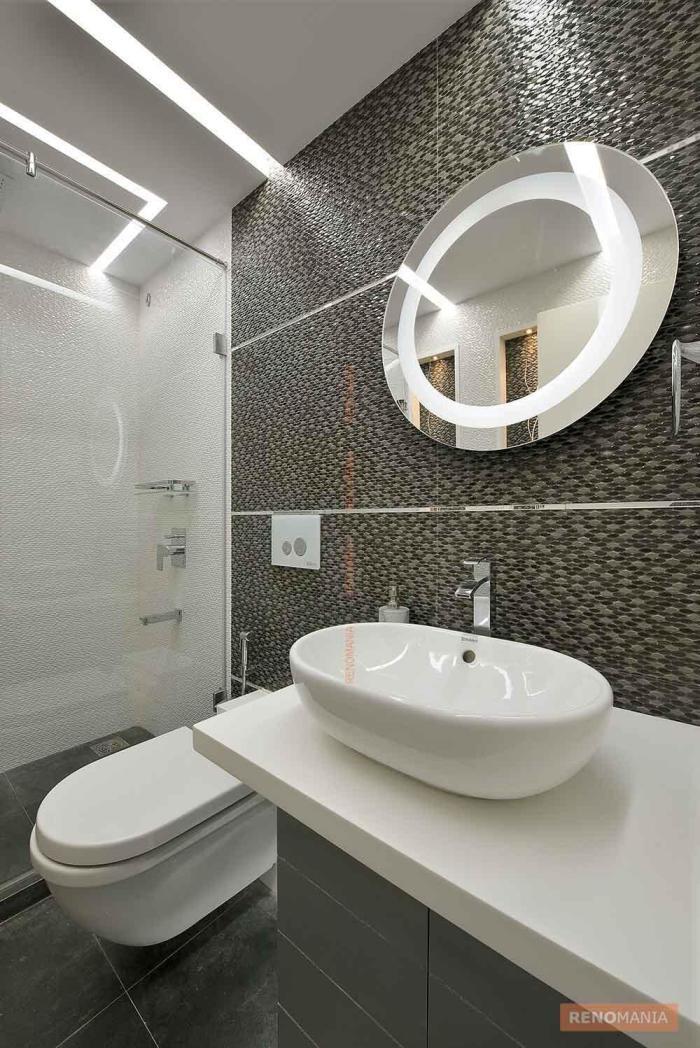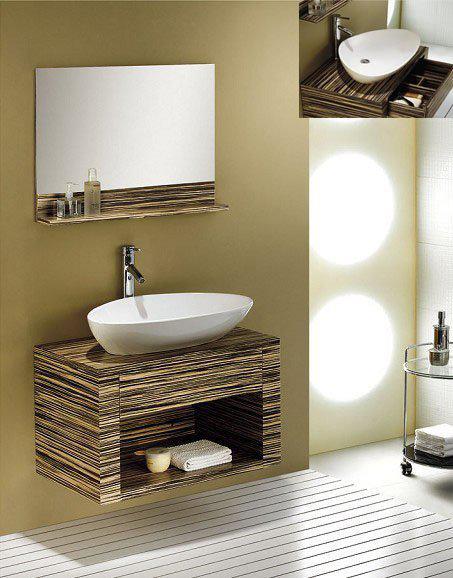The first image is the image on the left, the second image is the image on the right. For the images displayed, is the sentence "A window sits over the sink." factually correct? Answer yes or no. No. The first image is the image on the left, the second image is the image on the right. For the images shown, is this caption "An image shows a stainless steel, double basin sink with plants nearby." true? Answer yes or no. No. 